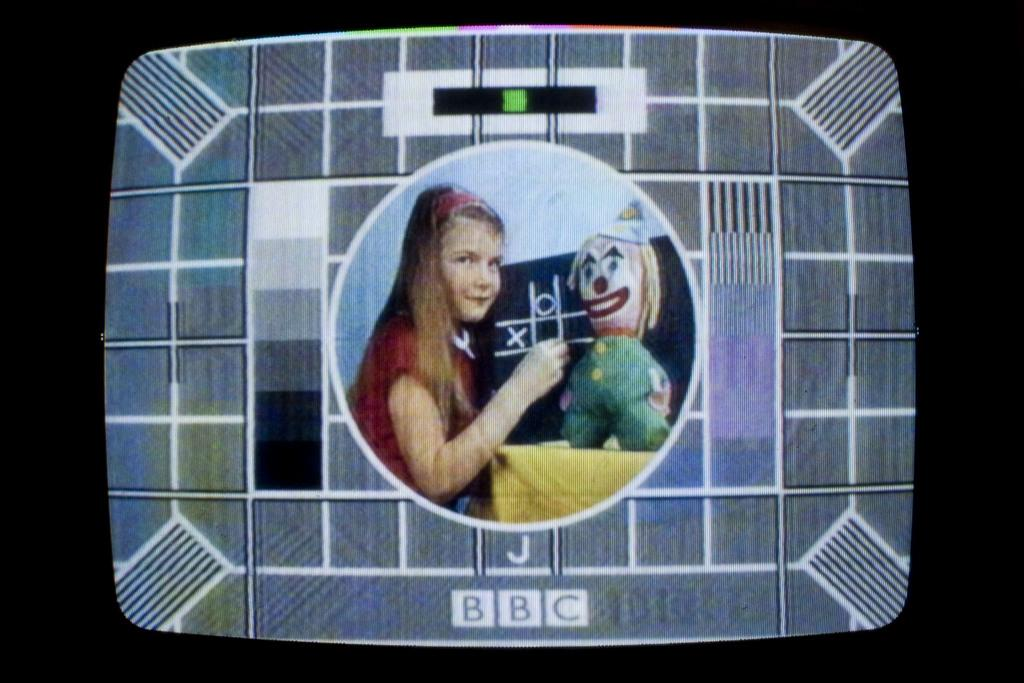What electronic device is present in the image? There is a television in the image. What is the television displaying? The television is displaying a picture. What can be seen in the picture on the television? The picture contains a child, a doll, and a board. What type of copper material is being twisted by the child in the image? There is no copper or twisting action present in the image. The child is not interacting with any material, and the picture only shows the child, doll, and board. 